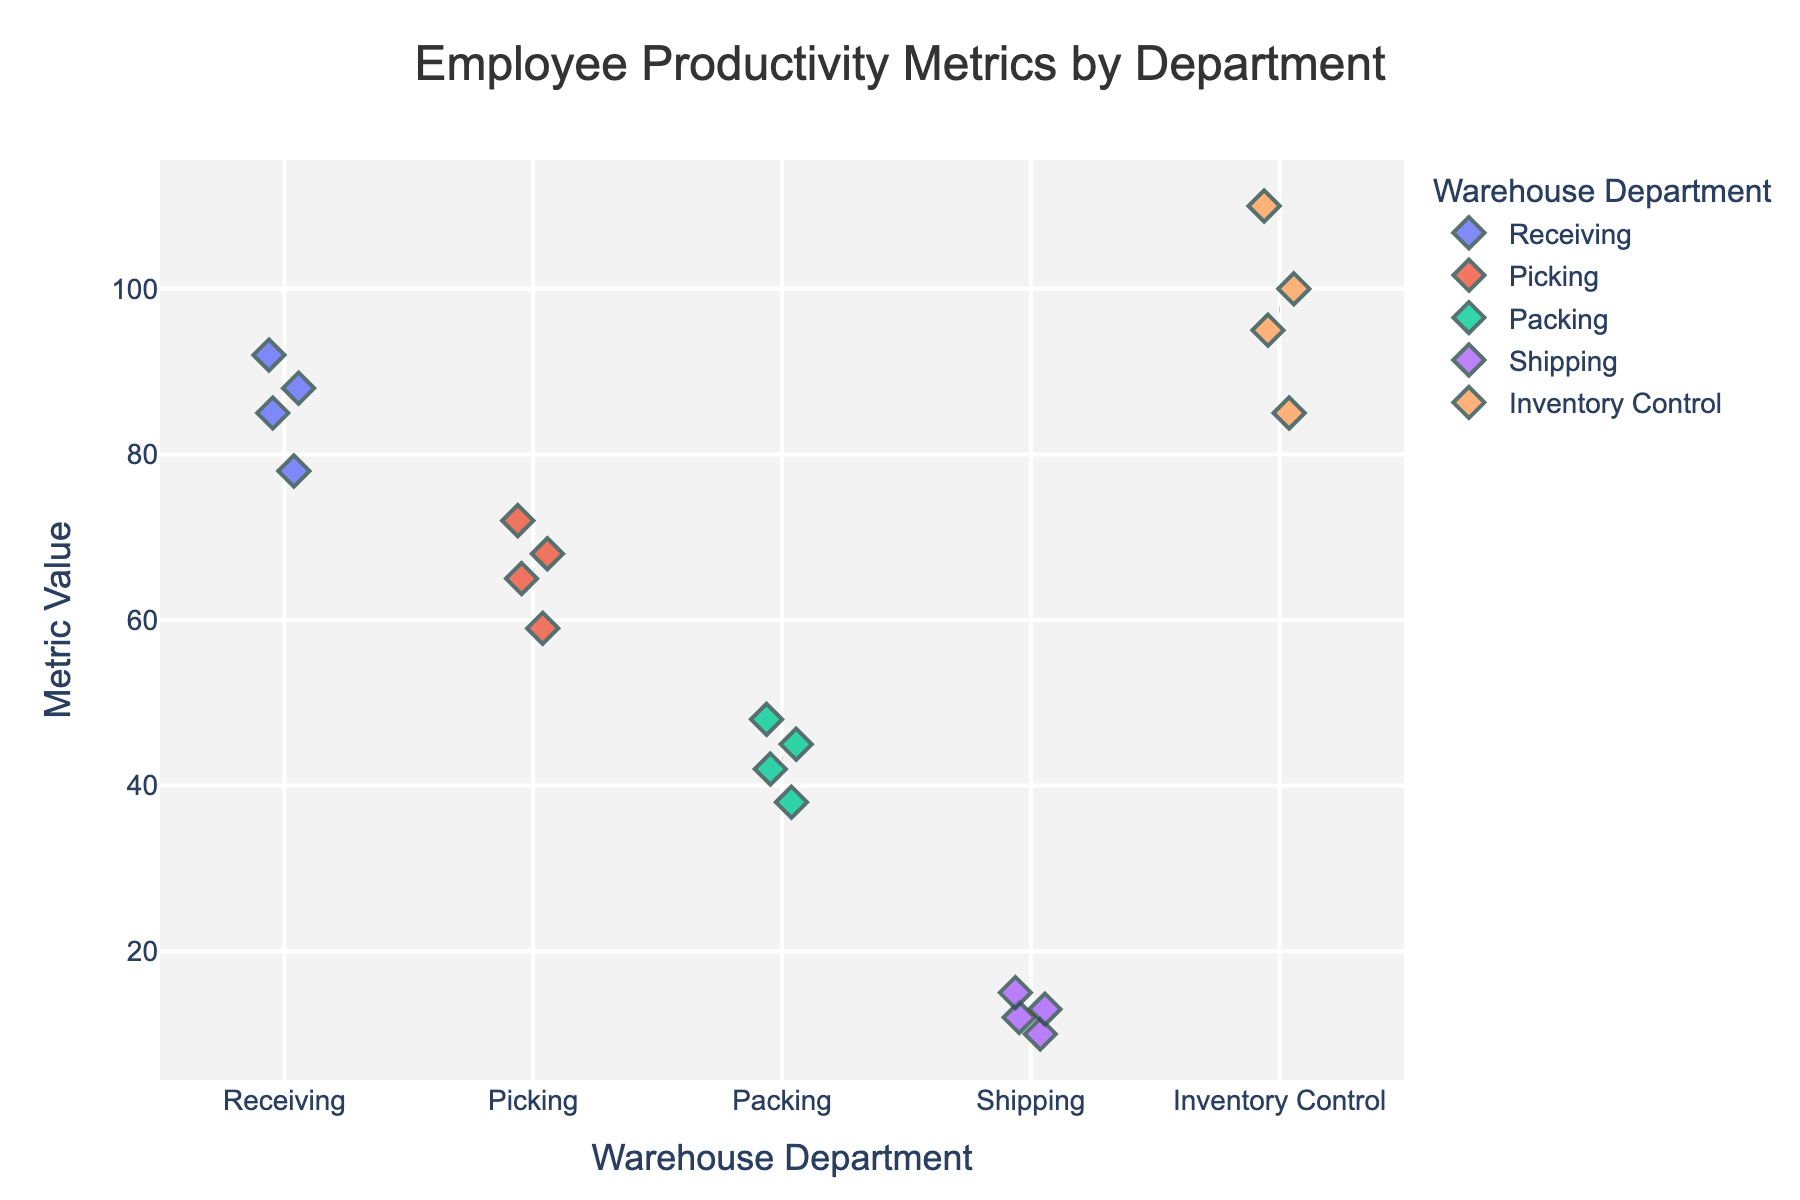what's the title of the figure? The title is displayed prominently at the top of the figure and summarizes the main focus of the plot.
Answer: Employee Productivity Metrics by Department what does the y-axis represent in this plot? The y-axis represents the productivity metrics values, indicating the quantitative measure of each department's performance as mentioned in the figure's labels.
Answer: Metric Value which department has the highest range of productivity metrics? By observing the spread of values (extent of points on the y-axis) for each department, we see that Inventory Control has points ranging from 85 to 110, the largest spread among departments.
Answer: Inventory Control how are the mean values for each department indicated? The mean values are marked by horizontal dashed red lines plotted for each department's data points.
Answer: Horizontal red dashed lines which department shows the highest individual productivity metric value? By checking the highest points on the y-axis across all departments, Inventory Control has the highest individual value of 110.
Answer: Inventory Control how many departments have a mean productivity metric below 50? By observing the positions of the red dashed lines, Packing and Shipping have their mean metrics below 50.
Answer: 2 which department has the least variability in productivity metrics? Variability can be assessed by looking at the spread of data points for each department. The Shipping department has a narrow range of points from 10 to 15, indicating the least variability.
Answer: Shipping compare the highest productivity metric value in Picking to the lowest in Receiving. The highest value in Picking is 72 and the lowest in Receiving is 78.
Answer: 6 units less in Picking which department has the lowest individual productivity metric value? Checking the lowest points on the y-axis across all departments, Shipping has the lowest at 10.
Answer: Shipping what is the mean productivity value for the Packing department? The mean value is indicated by the red dashed line, which is approximately between 42 and 45 based on visual inspection of the positioning of the line on the y-axis.
Answer: Around 43.5 